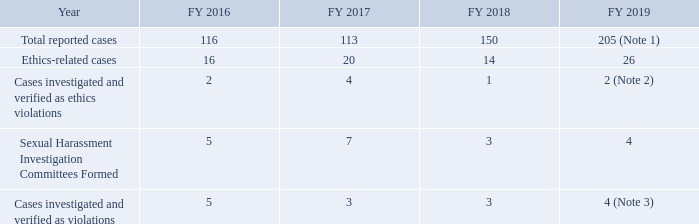Reporting Channels and Whistleblower Protection
To ensure that our conduct meets relevant legal requirements and the highest ethical standards under the Ethics Code, TSMC provides multiple channels for reporting business conduct concerns.
First of all, our Audit Committee approved and we have implemented the “Complaint Policy and Procedures for Certain Accounting and Legal Matters” and “Procedures for Ombudsman System” that allow employees or any whistleblowers with relevant evidence to report any financial, legal, or ethical irregularities anonymously through either the Ombudsman or directly to the Audit Committee.
TSMC maintains additional internal reporting channels for our employees. To foster an open culture of ethics compliance, we encourage our employees and the third parties we do business with to report any suspected noncompliance with law or relevant TSMC policy.
TSMC treats any complaint and the investigation thereof in a confidential and sensitive manner, and strictly prohibits any form of retaliation against any individual who in good faith reports or helps with the investigation of any complaint. Due to the open reporting channels, TSMC receives reports on various issues from employees and external parties such as our customers and suppliers from time to time. Below is a summary of the Number of Reported Incidents.
Note 1: Among the 205 cases, 132 were related to employee relationship, 47 cases related to other matters (e.g. employee’s individual interest or private matters), and 26 cases related to ethical matters.
Note 2: One case involved an employee who requested a supplier to reserve a hotel and pay advance accommodation fees during his business trip, actions which violate TSMC policy, and the employee was disciplined. Another case involved an employee who abused his work relationship by requesting a supplier to make a personal loan to the employee, a severe violation of our Ethics Code, and the employee was terminated.
Note 3: After the investigation by TSMC’s Sexual Harassment Investigation Committee, four employees involved in confirmed cases of sexual harassment received severe discipline from the Company.
Which process allow employees or any whistleblowers with relevant evidence to report any financial, legal, or ethical irregularities anonymously? “complaint policy and procedures for certain accounting and legal matters”, “procedures for ombudsman system”. What was the total reported cases in FY 16? 116. How many cases were reported related to employee relationship in 2019? 132. What is the change in Total reported cases from FY 2016 to FY 2017? 113-116
Answer: -3. What is the change in Ethics-related cases between FY 2016 and FY 2017? 20-16
Answer: 4. What is the change in Cases investigated and verified as ethics violations between FY 2016 and FY 2017? 4-2
Answer: 2. 